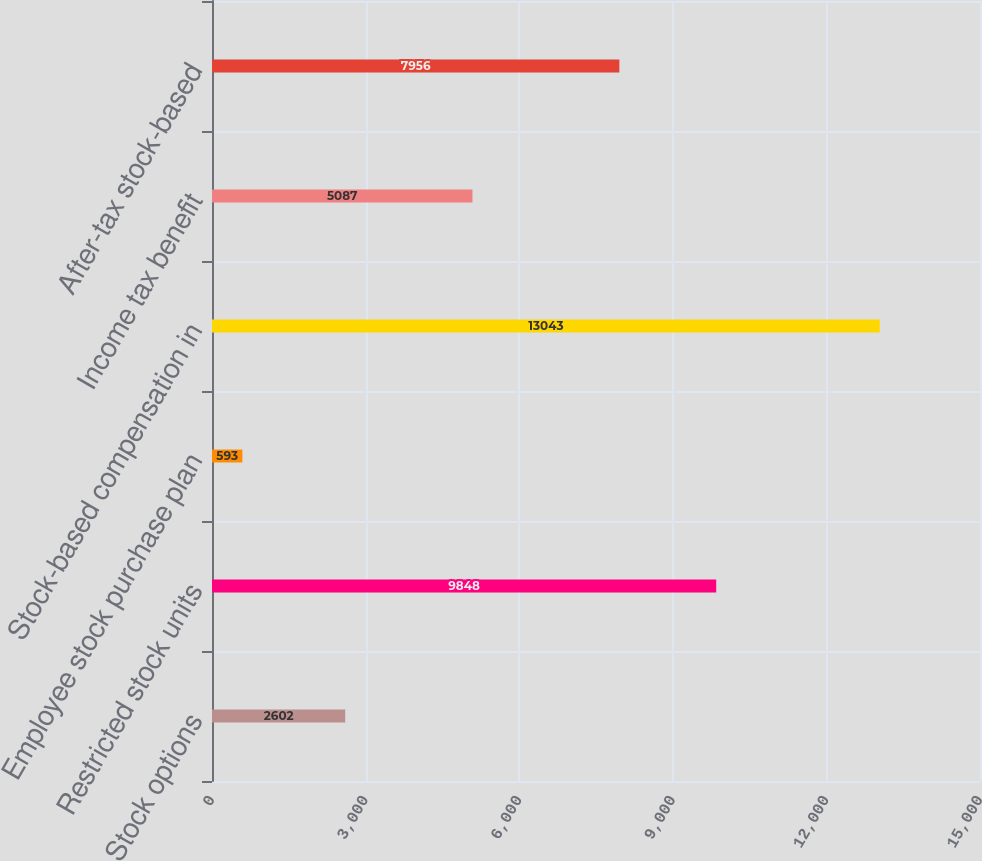Convert chart to OTSL. <chart><loc_0><loc_0><loc_500><loc_500><bar_chart><fcel>Stock options<fcel>Restricted stock units<fcel>Employee stock purchase plan<fcel>Stock-based compensation in<fcel>Income tax benefit<fcel>After-tax stock-based<nl><fcel>2602<fcel>9848<fcel>593<fcel>13043<fcel>5087<fcel>7956<nl></chart> 